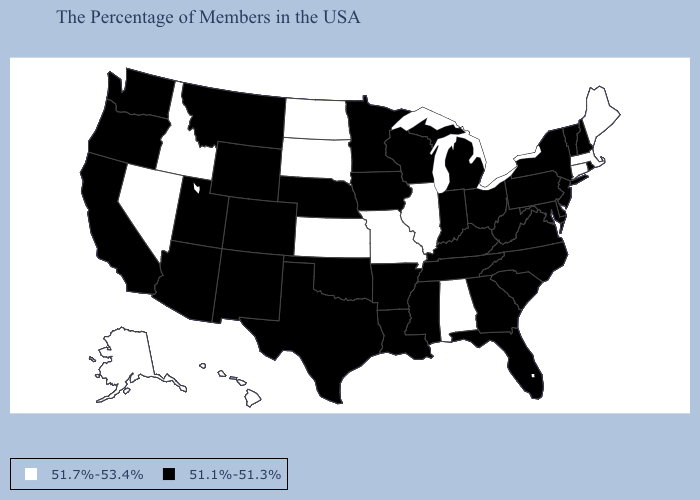Which states hav the highest value in the MidWest?
Short answer required. Illinois, Missouri, Kansas, South Dakota, North Dakota. Among the states that border Connecticut , does Rhode Island have the highest value?
Concise answer only. No. Among the states that border Rhode Island , which have the lowest value?
Be succinct. Massachusetts, Connecticut. What is the highest value in states that border Georgia?
Give a very brief answer. 51.7%-53.4%. What is the value of Texas?
Quick response, please. 51.1%-51.3%. Which states have the highest value in the USA?
Be succinct. Maine, Massachusetts, Connecticut, Alabama, Illinois, Missouri, Kansas, South Dakota, North Dakota, Idaho, Nevada, Alaska, Hawaii. Among the states that border Oklahoma , does Kansas have the lowest value?
Give a very brief answer. No. What is the value of Ohio?
Concise answer only. 51.1%-51.3%. Does Kansas have the same value as Florida?
Write a very short answer. No. Does Maryland have the lowest value in the USA?
Be succinct. Yes. Which states have the highest value in the USA?
Short answer required. Maine, Massachusetts, Connecticut, Alabama, Illinois, Missouri, Kansas, South Dakota, North Dakota, Idaho, Nevada, Alaska, Hawaii. Name the states that have a value in the range 51.7%-53.4%?
Give a very brief answer. Maine, Massachusetts, Connecticut, Alabama, Illinois, Missouri, Kansas, South Dakota, North Dakota, Idaho, Nevada, Alaska, Hawaii. Name the states that have a value in the range 51.7%-53.4%?
Be succinct. Maine, Massachusetts, Connecticut, Alabama, Illinois, Missouri, Kansas, South Dakota, North Dakota, Idaho, Nevada, Alaska, Hawaii. What is the highest value in the USA?
Keep it brief. 51.7%-53.4%. Does Pennsylvania have the lowest value in the Northeast?
Write a very short answer. Yes. 